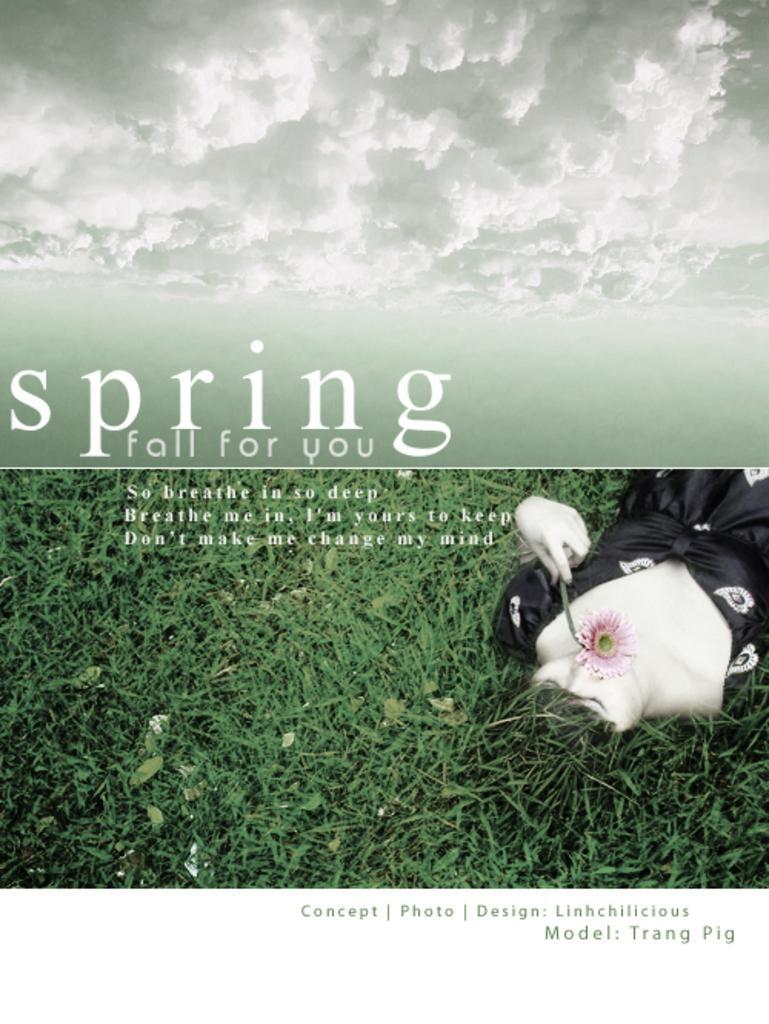Please provide a concise description of this image. In the image we can see a woman wearing clothes and she is lying, and holding a flower in hand. This is a grass, text and a cloudy sky. 